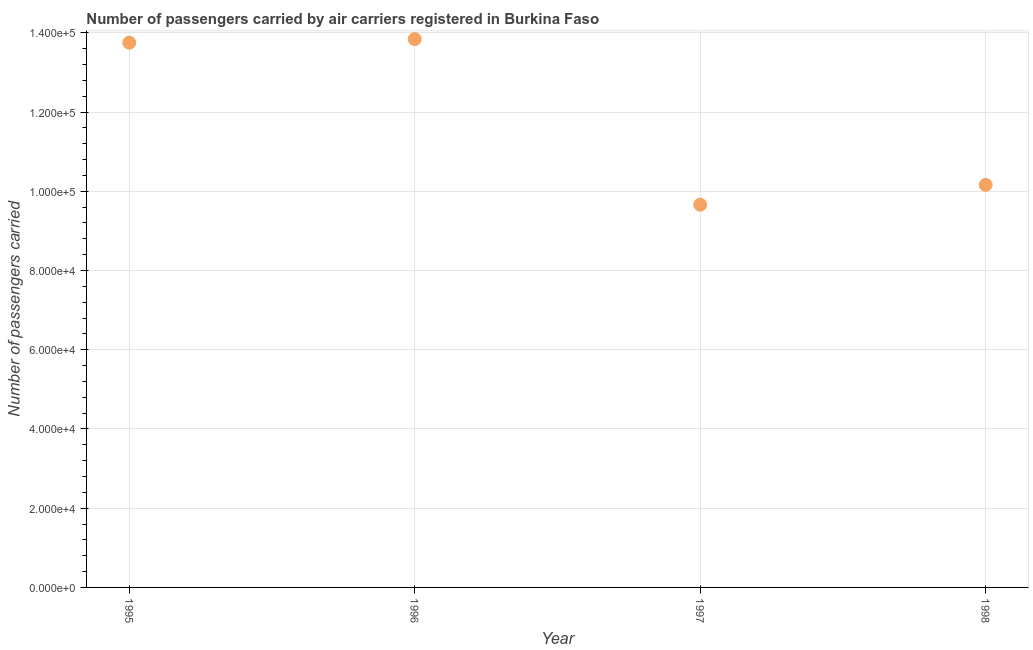What is the number of passengers carried in 1995?
Your answer should be very brief. 1.38e+05. Across all years, what is the maximum number of passengers carried?
Your answer should be very brief. 1.38e+05. Across all years, what is the minimum number of passengers carried?
Give a very brief answer. 9.66e+04. In which year was the number of passengers carried maximum?
Your answer should be compact. 1996. In which year was the number of passengers carried minimum?
Give a very brief answer. 1997. What is the sum of the number of passengers carried?
Provide a succinct answer. 4.74e+05. What is the difference between the number of passengers carried in 1996 and 1998?
Your answer should be compact. 3.68e+04. What is the average number of passengers carried per year?
Your answer should be very brief. 1.19e+05. What is the median number of passengers carried?
Provide a succinct answer. 1.20e+05. In how many years, is the number of passengers carried greater than 92000 ?
Your response must be concise. 4. What is the ratio of the number of passengers carried in 1997 to that in 1998?
Provide a short and direct response. 0.95. Is the number of passengers carried in 1995 less than that in 1997?
Keep it short and to the point. No. Is the difference between the number of passengers carried in 1995 and 1996 greater than the difference between any two years?
Your answer should be compact. No. What is the difference between the highest and the second highest number of passengers carried?
Give a very brief answer. 900. What is the difference between the highest and the lowest number of passengers carried?
Your response must be concise. 4.18e+04. How many years are there in the graph?
Provide a succinct answer. 4. What is the title of the graph?
Provide a short and direct response. Number of passengers carried by air carriers registered in Burkina Faso. What is the label or title of the Y-axis?
Your answer should be compact. Number of passengers carried. What is the Number of passengers carried in 1995?
Your response must be concise. 1.38e+05. What is the Number of passengers carried in 1996?
Provide a short and direct response. 1.38e+05. What is the Number of passengers carried in 1997?
Offer a very short reply. 9.66e+04. What is the Number of passengers carried in 1998?
Offer a very short reply. 1.02e+05. What is the difference between the Number of passengers carried in 1995 and 1996?
Your answer should be compact. -900. What is the difference between the Number of passengers carried in 1995 and 1997?
Make the answer very short. 4.09e+04. What is the difference between the Number of passengers carried in 1995 and 1998?
Provide a short and direct response. 3.59e+04. What is the difference between the Number of passengers carried in 1996 and 1997?
Keep it short and to the point. 4.18e+04. What is the difference between the Number of passengers carried in 1996 and 1998?
Make the answer very short. 3.68e+04. What is the difference between the Number of passengers carried in 1997 and 1998?
Your answer should be compact. -5000. What is the ratio of the Number of passengers carried in 1995 to that in 1997?
Your answer should be very brief. 1.42. What is the ratio of the Number of passengers carried in 1995 to that in 1998?
Provide a short and direct response. 1.35. What is the ratio of the Number of passengers carried in 1996 to that in 1997?
Your answer should be very brief. 1.43. What is the ratio of the Number of passengers carried in 1996 to that in 1998?
Offer a terse response. 1.36. What is the ratio of the Number of passengers carried in 1997 to that in 1998?
Provide a short and direct response. 0.95. 